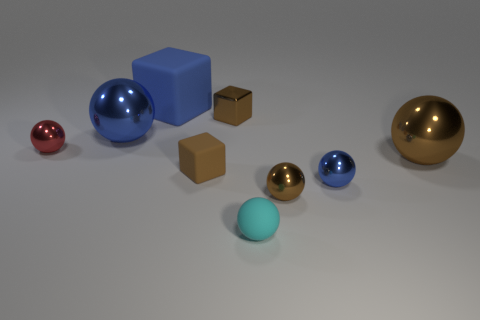Subtract 1 balls. How many balls are left? 5 Subtract all cyan balls. How many balls are left? 5 Subtract all red shiny spheres. How many spheres are left? 5 Subtract all red balls. Subtract all red cylinders. How many balls are left? 5 Add 1 big blue rubber blocks. How many objects exist? 10 Subtract all cubes. How many objects are left? 6 Add 5 tiny red things. How many tiny red things are left? 6 Add 3 red metal objects. How many red metal objects exist? 4 Subtract 0 red cylinders. How many objects are left? 9 Subtract all small cyan rubber blocks. Subtract all big blue cubes. How many objects are left? 8 